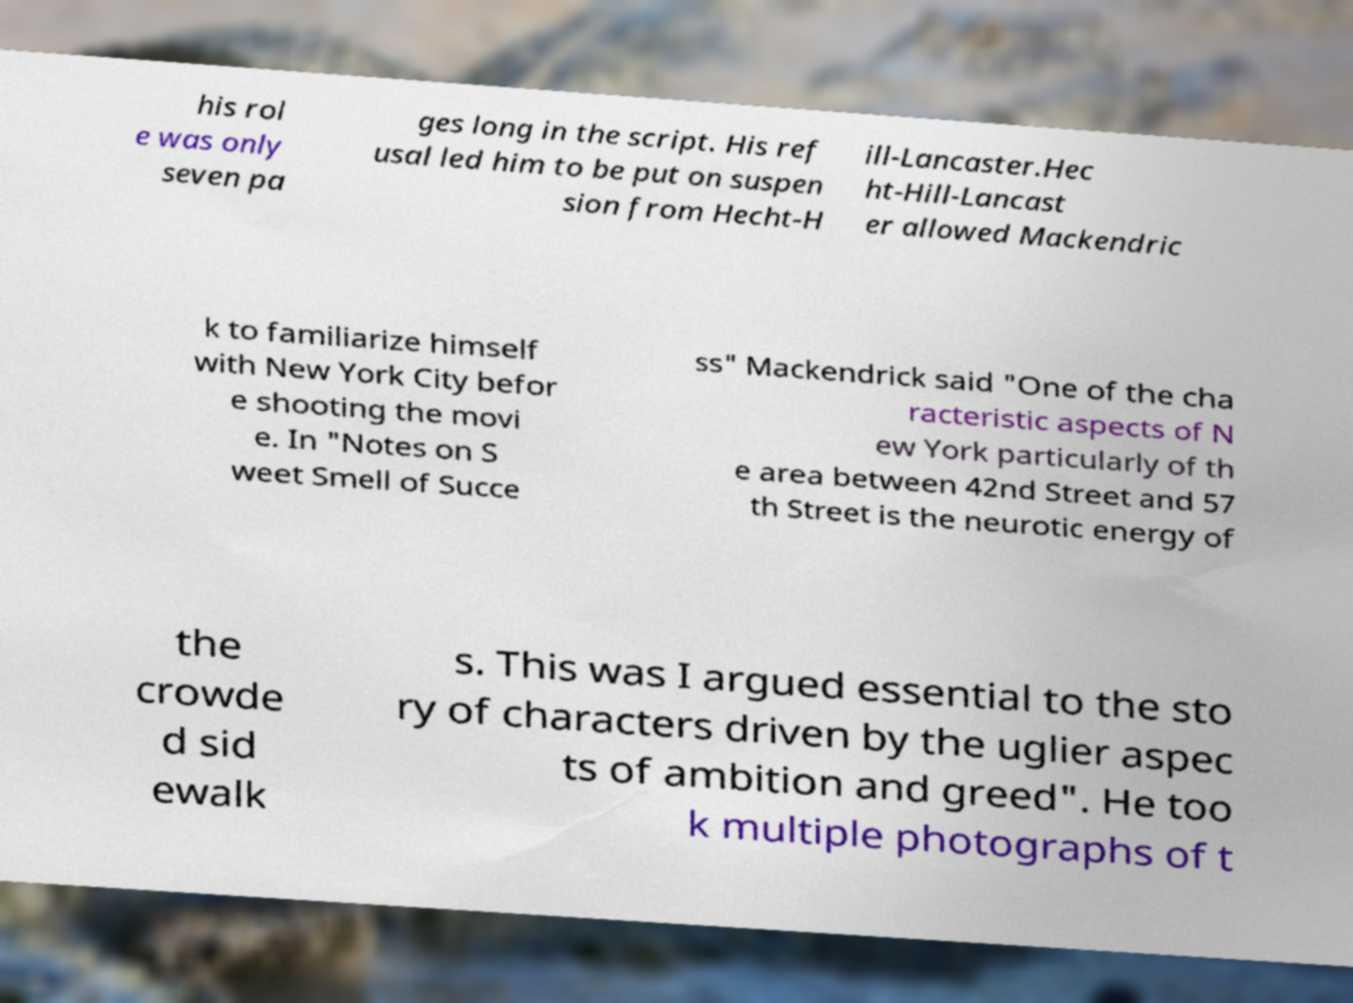Please read and relay the text visible in this image. What does it say? his rol e was only seven pa ges long in the script. His ref usal led him to be put on suspen sion from Hecht-H ill-Lancaster.Hec ht-Hill-Lancast er allowed Mackendric k to familiarize himself with New York City befor e shooting the movi e. In "Notes on S weet Smell of Succe ss" Mackendrick said "One of the cha racteristic aspects of N ew York particularly of th e area between 42nd Street and 57 th Street is the neurotic energy of the crowde d sid ewalk s. This was I argued essential to the sto ry of characters driven by the uglier aspec ts of ambition and greed". He too k multiple photographs of t 